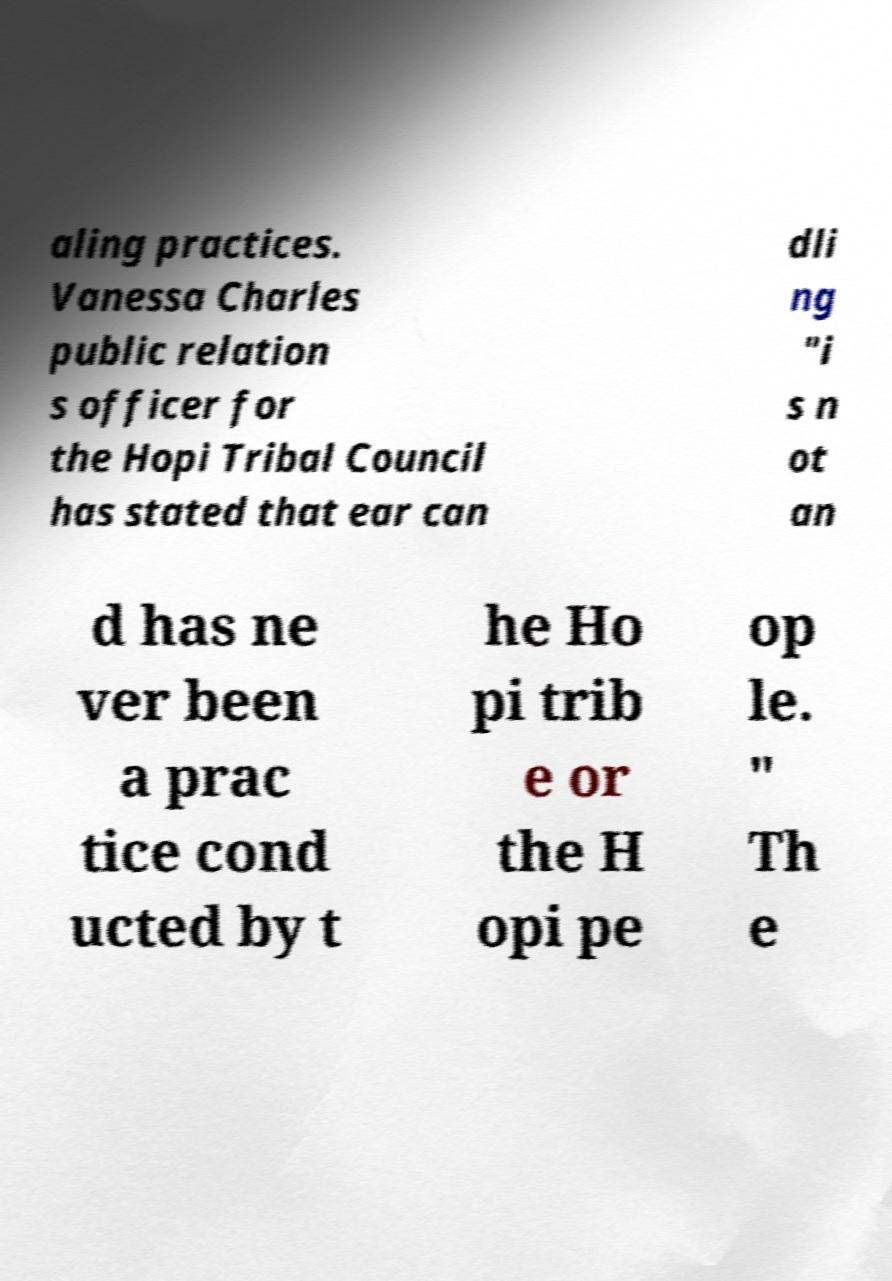Can you accurately transcribe the text from the provided image for me? aling practices. Vanessa Charles public relation s officer for the Hopi Tribal Council has stated that ear can dli ng "i s n ot an d has ne ver been a prac tice cond ucted by t he Ho pi trib e or the H opi pe op le. " Th e 